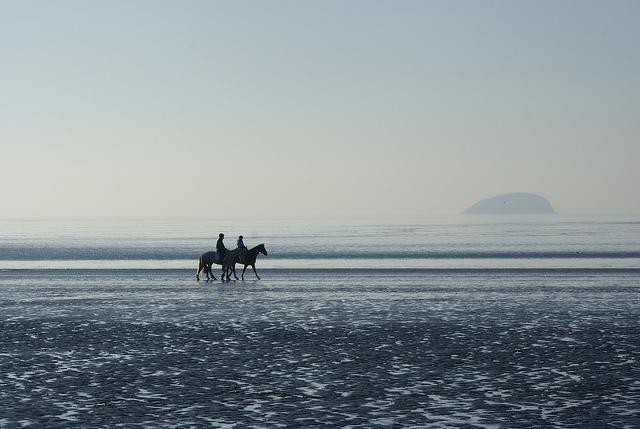What is the man holding?
Write a very short answer. Reins. Are there sailboats on the water?
Write a very short answer. No. What keeps the man from going underwater?
Write a very short answer. Horse. What are the animals walking in?
Answer briefly. Water. How deep is the water?
Short answer required. Shallow. What is the man doing?
Keep it brief. Horseback riding. Is it windy?
Give a very brief answer. No. Are these people flying kites?
Write a very short answer. No. Is there a bird in the picture?
Answer briefly. No. Is the water calm?
Quick response, please. Yes. Are there birds in the sky?
Be succinct. No. What animal is walking in the distance?
Keep it brief. Horse. What animal is in this sense?
Concise answer only. Horse. Is the sky color that of a sunset?
Be succinct. No. 